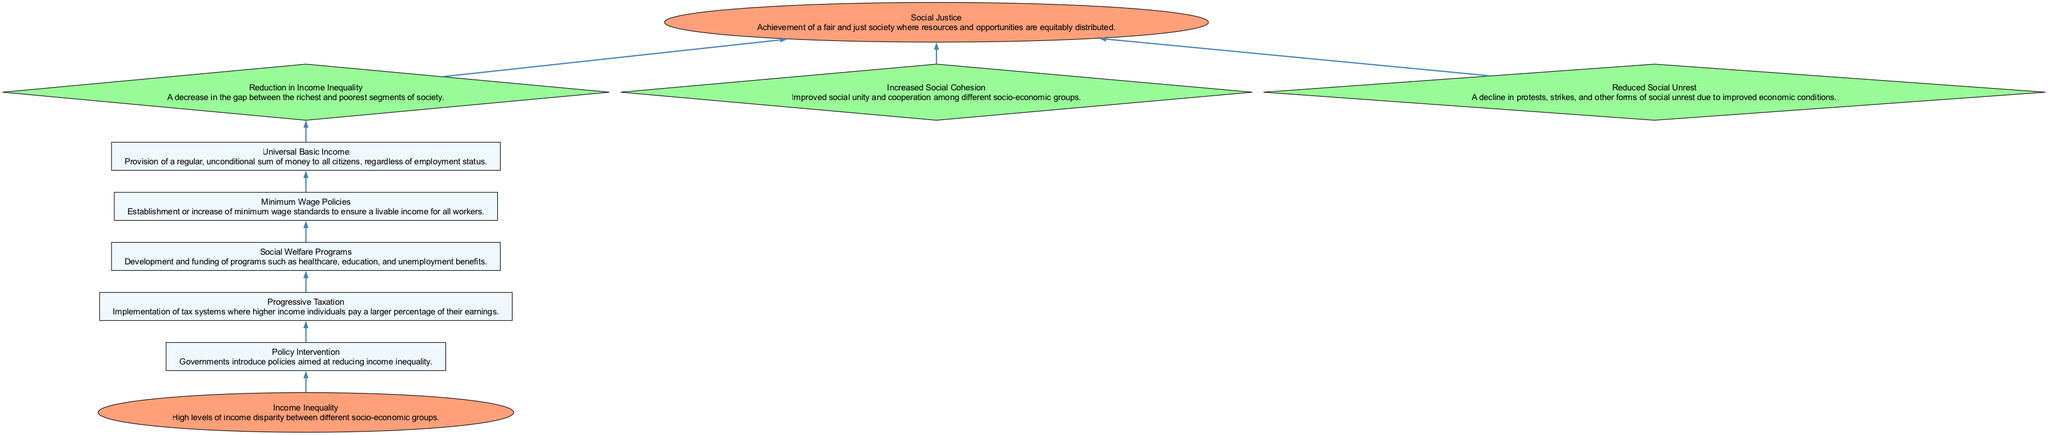What is the starting point of this diagram? The starting point of the diagram is labeled "Income Inequality," indicating that the process begins with high levels of income disparity between socio-economic groups.
Answer: Income Inequality How many steps are there in the diagram? The diagram includes five steps, each representing a mechanism for income redistribution, leading towards social justice.
Answer: 5 What type of node is "Universal Basic Income"? "Universal Basic Income" is categorized as a step in the flow chart, represented by a rectangular node detailing the provision of regular, unconditional money to citizens.
Answer: Step What outcome directly follows "Social Welfare Programs"? The outcome that follows "Social Welfare Programs" is "Reduction in Income Inequality," which illustrates a positive effect of implementing social welfare initiatives.
Answer: Reduction in Income Inequality Which outcome is the final result of the diagram? The final outcome of the diagram is "Social Justice," signifying the end goal of achieving a fair and just society with equitable resource distribution.
Answer: Social Justice How does "Progressive Taxation" connect to "Reduced Social Unrest"? "Progressive Taxation" leads to the outcome "Reduction in Income Inequality," which, when achieved, results in "Reduced Social Unrest," showing a direct connection where effective taxation impacts social stability.
Answer: By reducing income inequality What are the three outcomes listed in the diagram? The three outcomes listed are "Reduction in Income Inequality," "Increased Social Cohesion," and "Reduced Social Unrest," demonstrating different effects resulting from the steps taken.
Answer: Reduction in Income Inequality, Increased Social Cohesion, Reduced Social Unrest Which step is followed by "Minimum Wage Policies"? "Minimum Wage Policies" is preceded by "Social Welfare Programs," indicating the order of implementation within the pathway towards social justice.
Answer: Social Welfare Programs What is the relationship between "Income Inequality" and "Social Justice"? The relationship indicates that addressing "Income Inequality" through various steps ultimately aims to achieve "Social Justice," linking the starting point to the end goal.
Answer: Pathway to Social Justice 